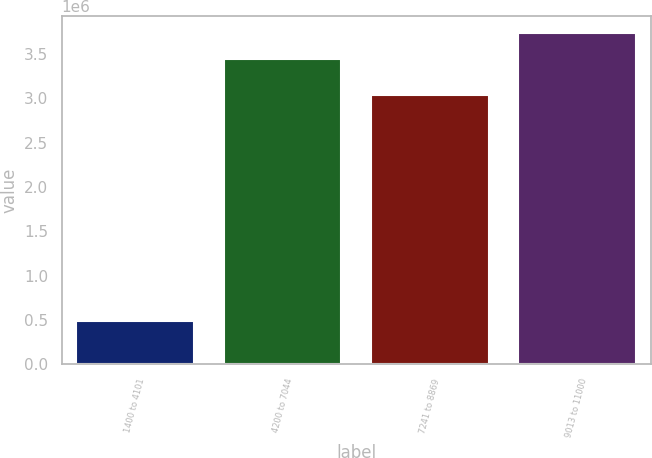Convert chart. <chart><loc_0><loc_0><loc_500><loc_500><bar_chart><fcel>1400 to 4101<fcel>4200 to 7044<fcel>7241 to 8869<fcel>9013 to 11000<nl><fcel>489290<fcel>3.44282e+06<fcel>3.04186e+06<fcel>3.74196e+06<nl></chart> 